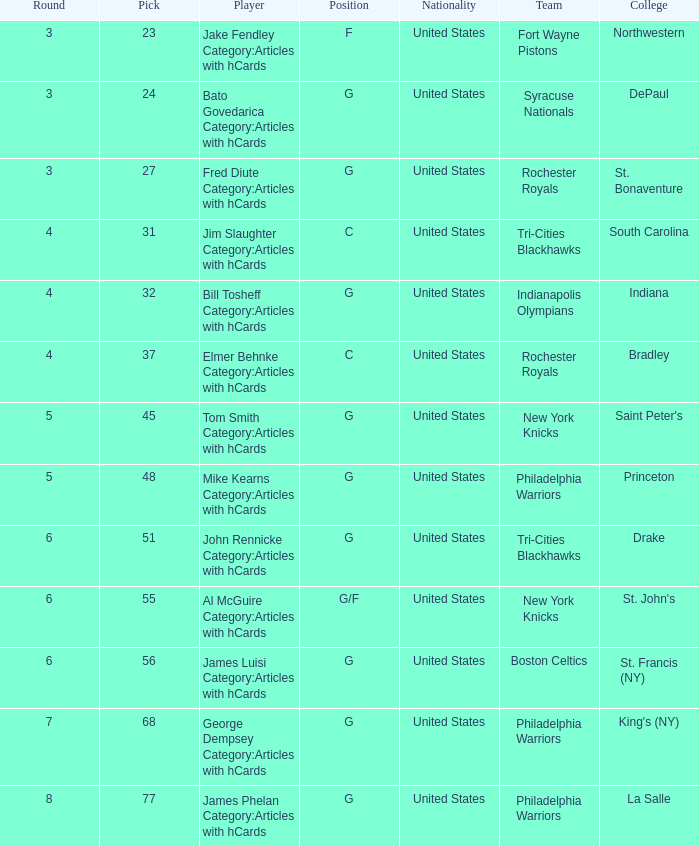What is the cumulative number of selections for drake players from the tri-cities blackhawks? 51.0. 